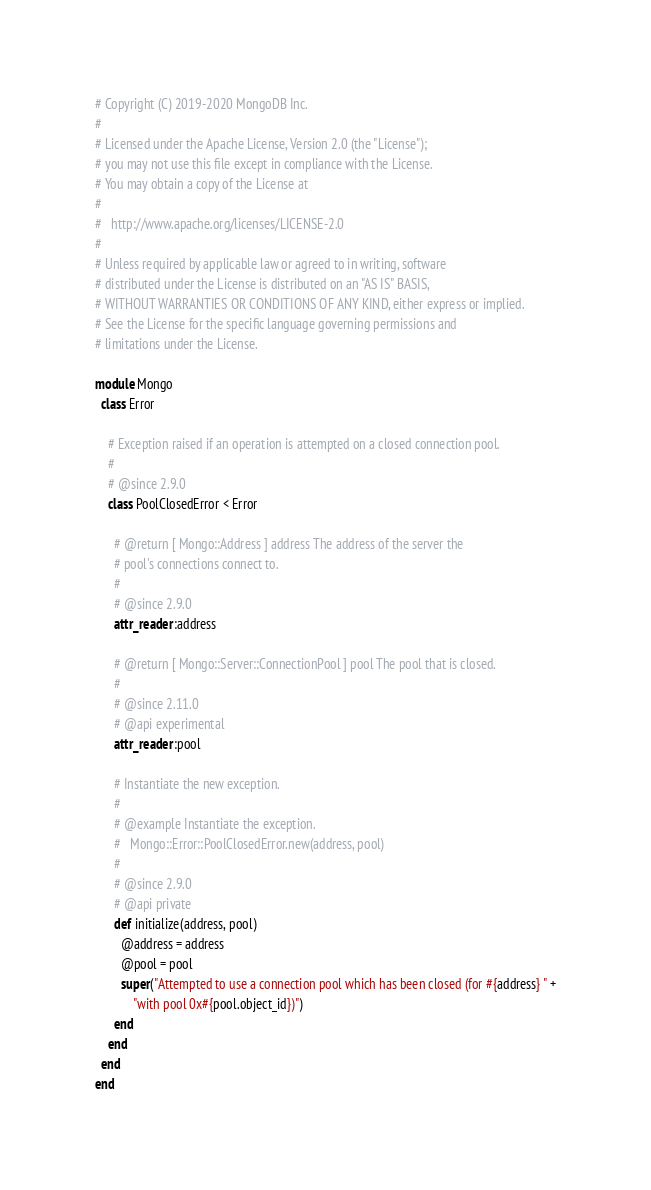<code> <loc_0><loc_0><loc_500><loc_500><_Ruby_># Copyright (C) 2019-2020 MongoDB Inc.
#
# Licensed under the Apache License, Version 2.0 (the "License");
# you may not use this file except in compliance with the License.
# You may obtain a copy of the License at
#
#   http://www.apache.org/licenses/LICENSE-2.0
#
# Unless required by applicable law or agreed to in writing, software
# distributed under the License is distributed on an "AS IS" BASIS,
# WITHOUT WARRANTIES OR CONDITIONS OF ANY KIND, either express or implied.
# See the License for the specific language governing permissions and
# limitations under the License.

module Mongo
  class Error

    # Exception raised if an operation is attempted on a closed connection pool.
    #
    # @since 2.9.0
    class PoolClosedError < Error

      # @return [ Mongo::Address ] address The address of the server the
      # pool's connections connect to.
      #
      # @since 2.9.0
      attr_reader :address

      # @return [ Mongo::Server::ConnectionPool ] pool The pool that is closed.
      #
      # @since 2.11.0
      # @api experimental
      attr_reader :pool

      # Instantiate the new exception.
      #
      # @example Instantiate the exception.
      #   Mongo::Error::PoolClosedError.new(address, pool)
      #
      # @since 2.9.0
      # @api private
      def initialize(address, pool)
        @address = address
        @pool = pool
        super("Attempted to use a connection pool which has been closed (for #{address} " +
            "with pool 0x#{pool.object_id})")
      end
    end
  end
end
</code> 